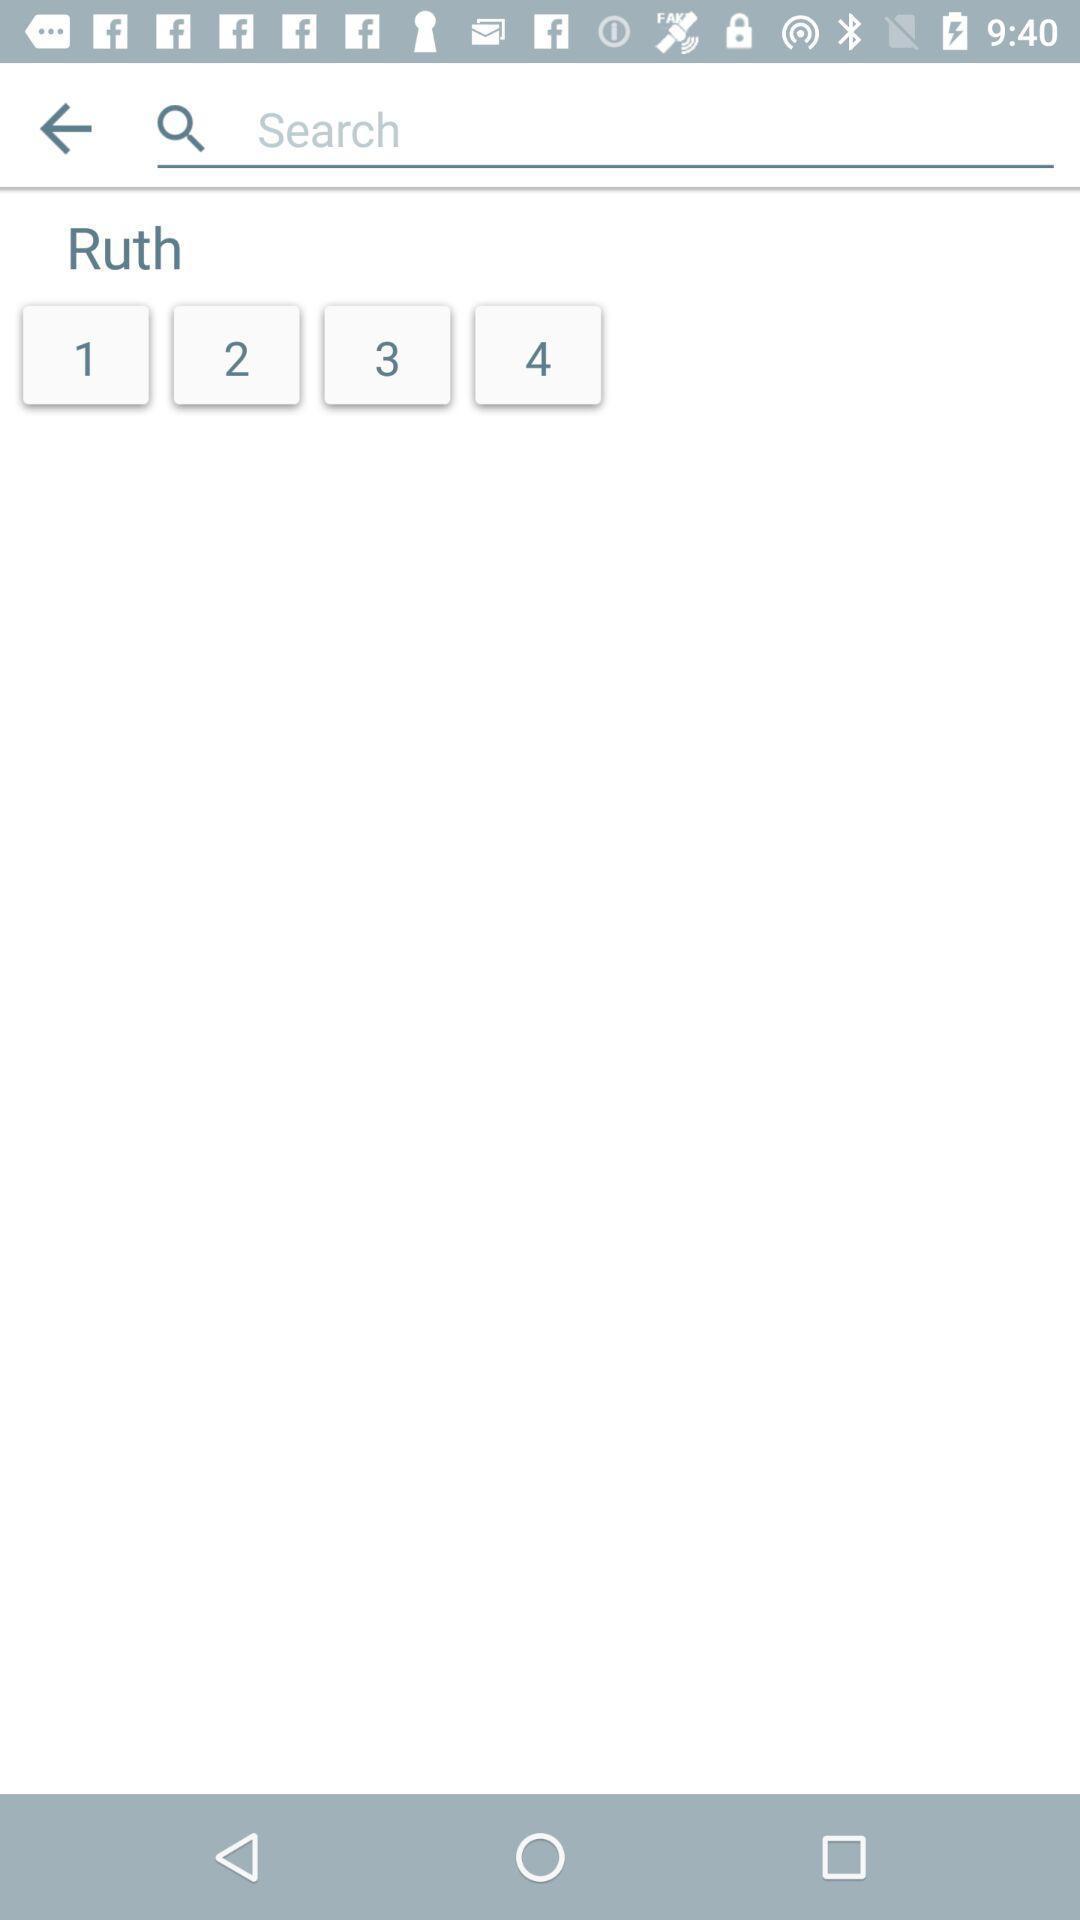Summarize the main components in this picture. Search option to find content in a religious app. 